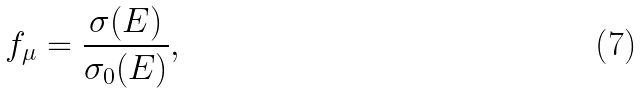Convert formula to latex. <formula><loc_0><loc_0><loc_500><loc_500>f _ { \mu } = \frac { \sigma ( E ) } { \sigma _ { 0 } ( E ) } ,</formula> 